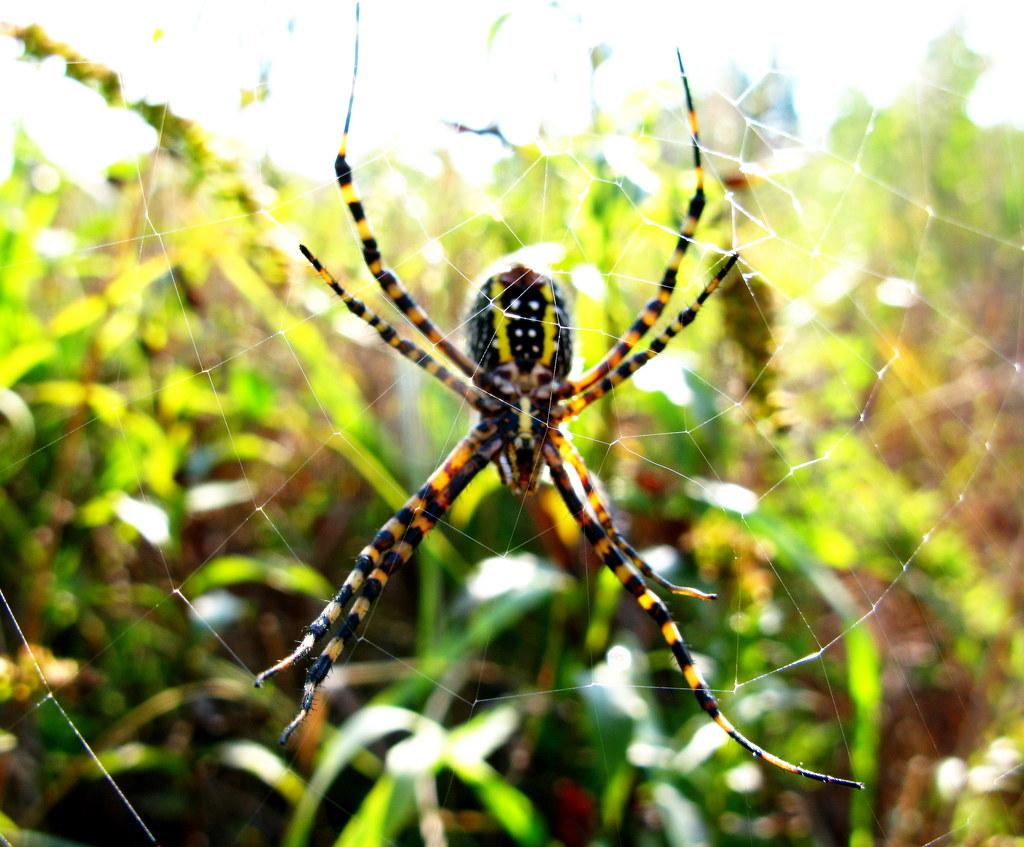What is the main subject of the image? The main subject of the image is a spider. Can you describe the appearance of the spider? The spider has a black and yellow color combination. Where is the spider located in the image? The spider is on a web. How would you describe the background of the image? The background of the image is blurred. What type of apple is being held by the spider in the image? There is no apple present in the image; the spider is on a web. How does the balloon affect the spider's movement in the image? There is no balloon present in the image, so it does not affect the spider's movement. 